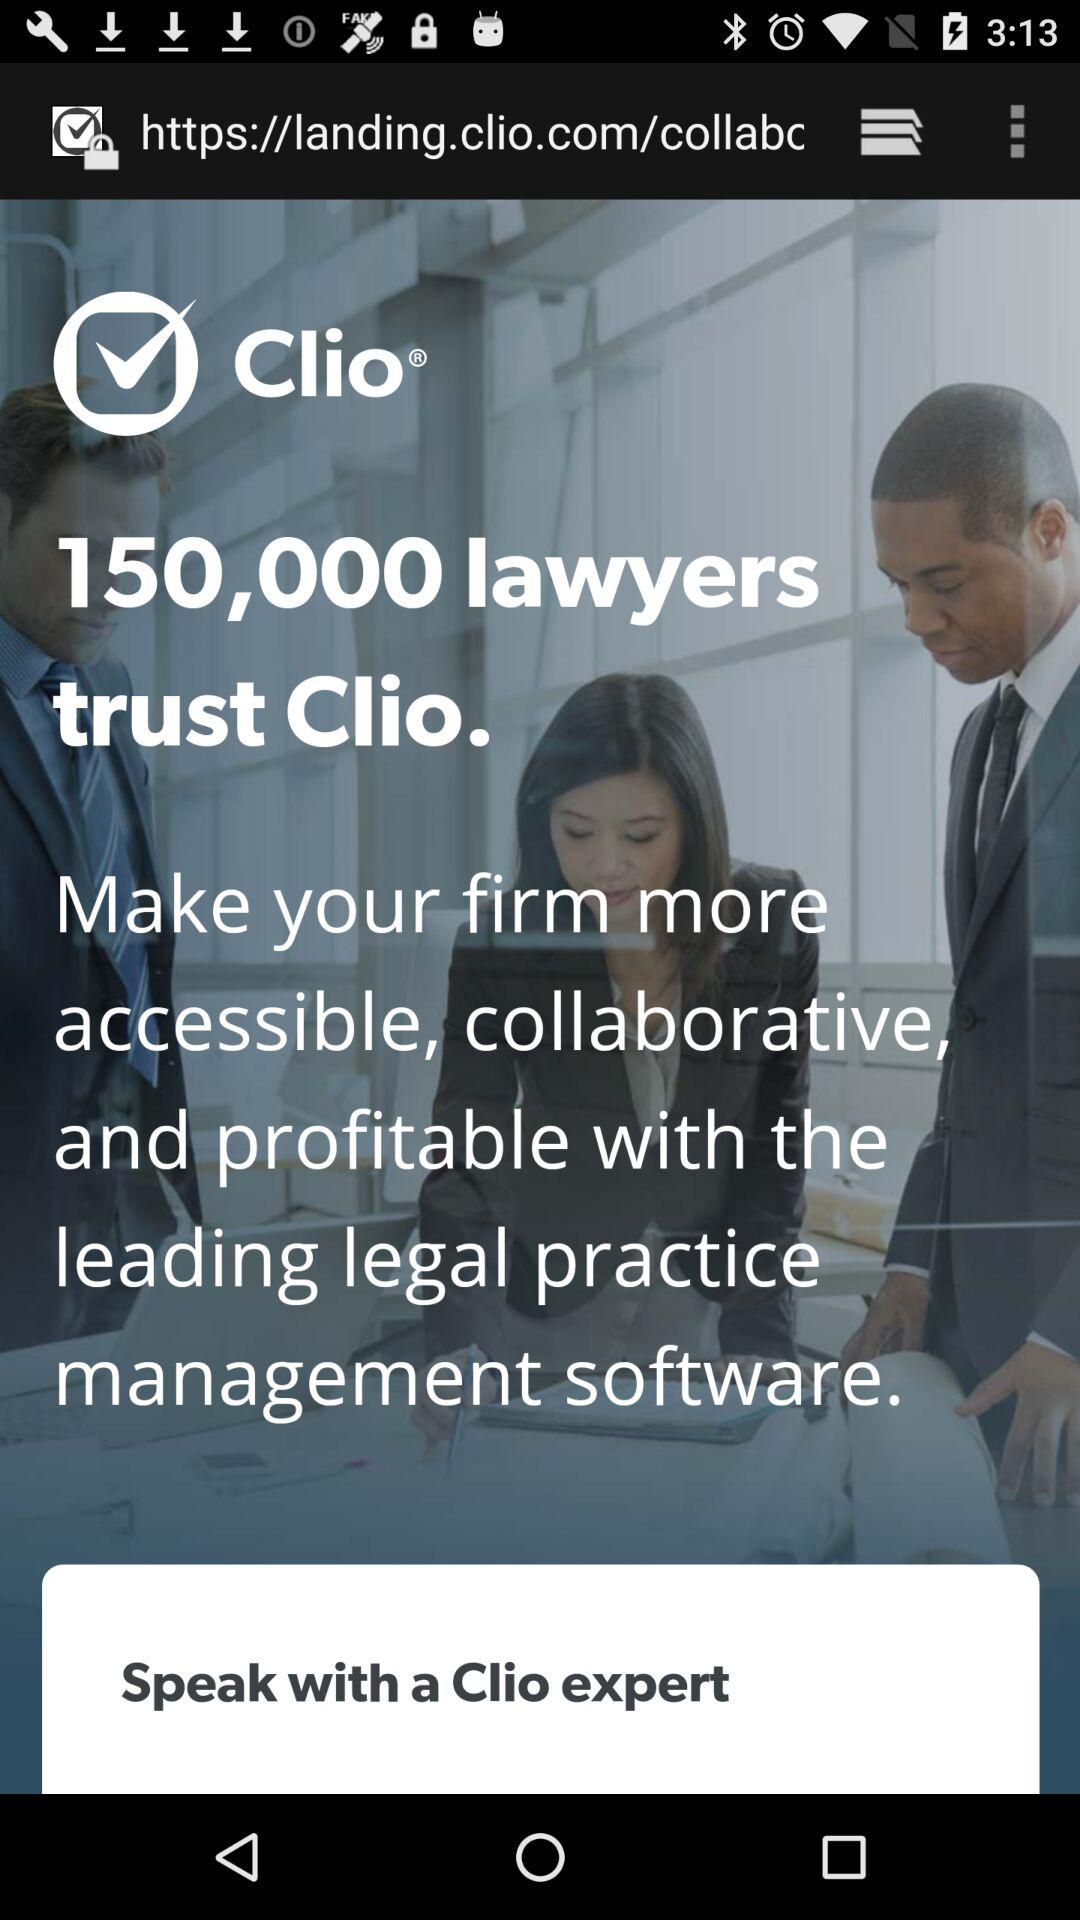What is the application name? The application name is "Clio". 